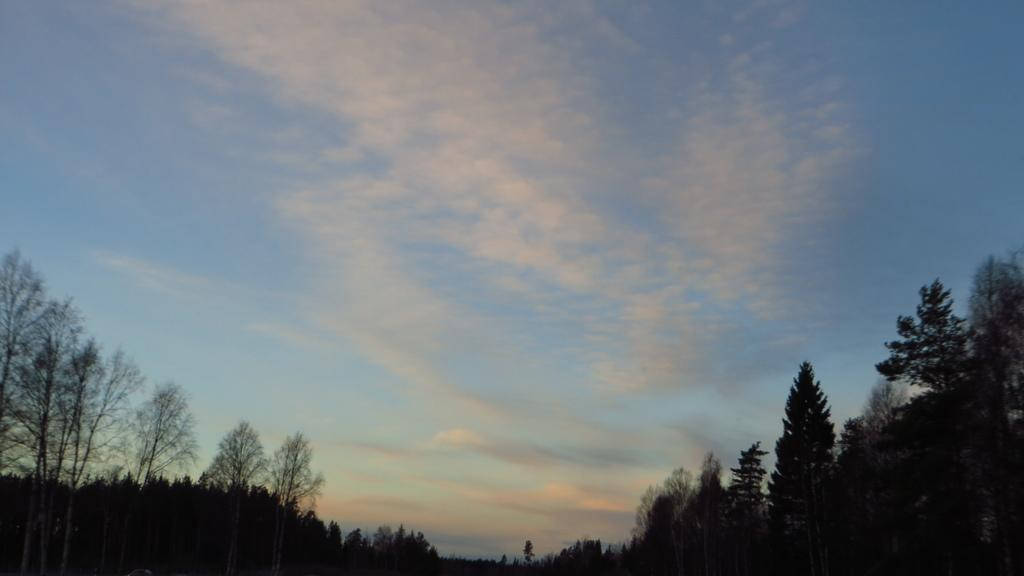Where was the picture taken? The picture was clicked outside. What can be seen in the foreground of the image? There are trees in the foreground of the image. What is visible in the background of the image? The sky is visible in the background of the image. What can be observed in the sky? Clouds are present in the sky. How many balls is the grandfather holding in the image? There is no grandfather or balls present in the image. What color is the tongue of the person in the image? There is no person or tongue present in the image. 